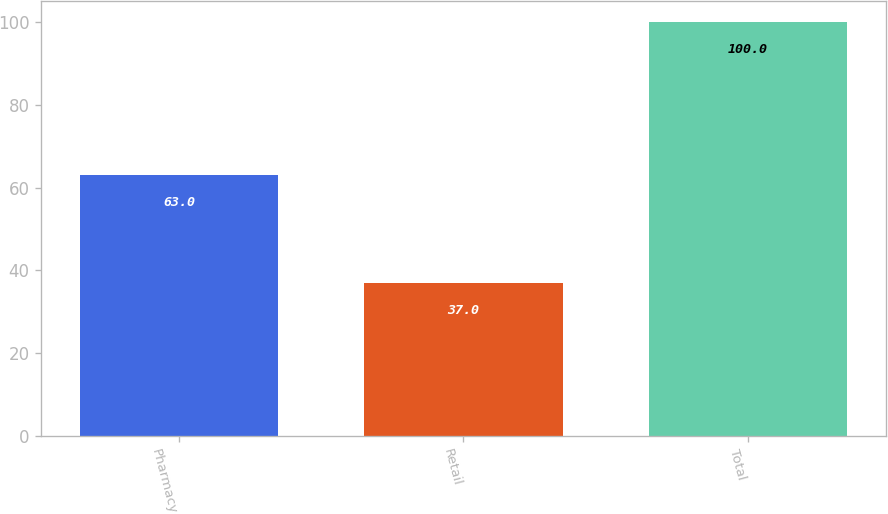Convert chart to OTSL. <chart><loc_0><loc_0><loc_500><loc_500><bar_chart><fcel>Pharmacy<fcel>Retail<fcel>Total<nl><fcel>63<fcel>37<fcel>100<nl></chart> 